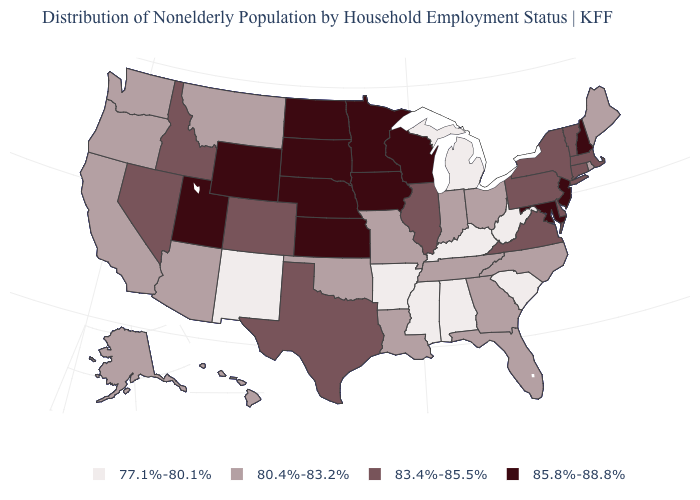What is the value of West Virginia?
Answer briefly. 77.1%-80.1%. What is the value of Arkansas?
Write a very short answer. 77.1%-80.1%. What is the value of Arkansas?
Be succinct. 77.1%-80.1%. Which states hav the highest value in the Northeast?
Quick response, please. New Hampshire, New Jersey. Does Maine have a higher value than Florida?
Concise answer only. No. What is the lowest value in the Northeast?
Concise answer only. 80.4%-83.2%. What is the highest value in the USA?
Short answer required. 85.8%-88.8%. What is the value of Louisiana?
Short answer required. 80.4%-83.2%. Which states have the lowest value in the USA?
Quick response, please. Alabama, Arkansas, Kentucky, Michigan, Mississippi, New Mexico, South Carolina, West Virginia. Name the states that have a value in the range 85.8%-88.8%?
Quick response, please. Iowa, Kansas, Maryland, Minnesota, Nebraska, New Hampshire, New Jersey, North Dakota, South Dakota, Utah, Wisconsin, Wyoming. Does Maryland have the highest value in the South?
Quick response, please. Yes. Does the first symbol in the legend represent the smallest category?
Quick response, please. Yes. Among the states that border West Virginia , which have the lowest value?
Short answer required. Kentucky. What is the value of Montana?
Write a very short answer. 80.4%-83.2%. Is the legend a continuous bar?
Keep it brief. No. 